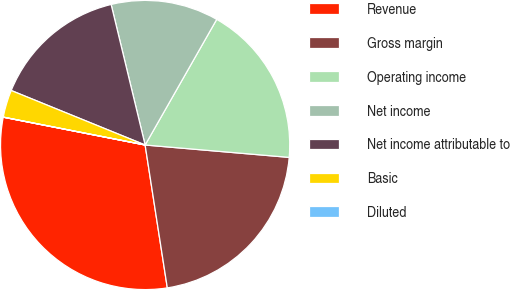<chart> <loc_0><loc_0><loc_500><loc_500><pie_chart><fcel>Revenue<fcel>Gross margin<fcel>Operating income<fcel>Net income<fcel>Net income attributable to<fcel>Basic<fcel>Diluted<nl><fcel>30.53%<fcel>21.18%<fcel>18.12%<fcel>12.02%<fcel>15.07%<fcel>3.06%<fcel>0.01%<nl></chart> 